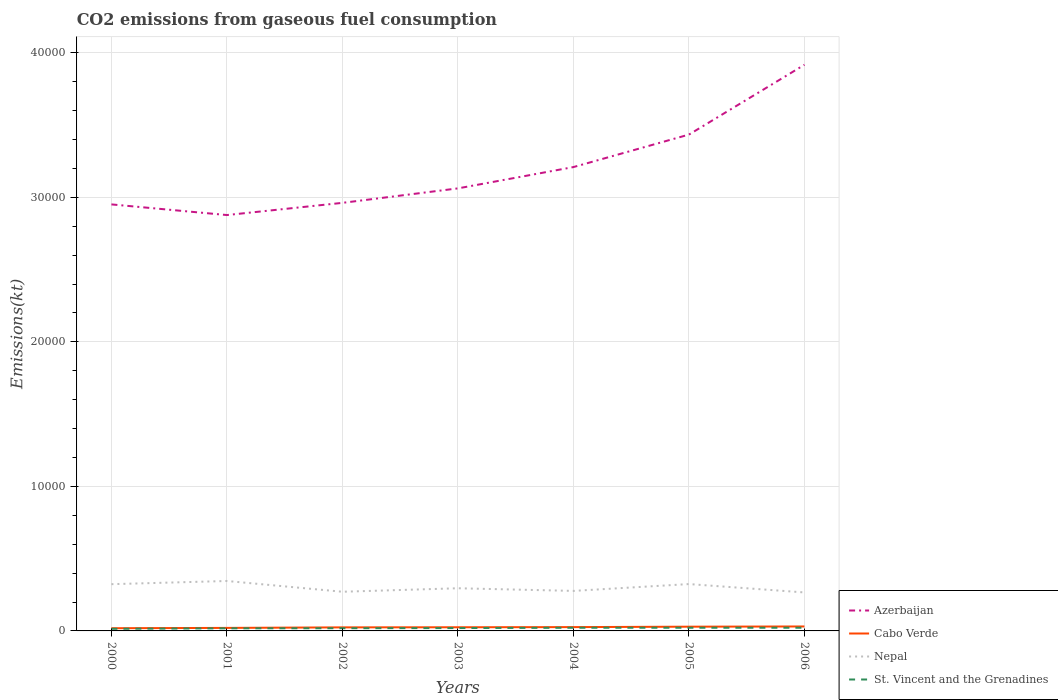Across all years, what is the maximum amount of CO2 emitted in Cabo Verde?
Provide a succinct answer. 187.02. What is the total amount of CO2 emitted in Azerbaijan in the graph?
Your response must be concise. -2247.87. What is the difference between the highest and the second highest amount of CO2 emitted in Nepal?
Your answer should be very brief. 792.07. How many years are there in the graph?
Your answer should be compact. 7. Does the graph contain any zero values?
Provide a succinct answer. No. How many legend labels are there?
Offer a terse response. 4. What is the title of the graph?
Offer a very short reply. CO2 emissions from gaseous fuel consumption. Does "Sint Maarten (Dutch part)" appear as one of the legend labels in the graph?
Your answer should be compact. No. What is the label or title of the Y-axis?
Your response must be concise. Emissions(kt). What is the Emissions(kt) in Azerbaijan in 2000?
Offer a terse response. 2.95e+04. What is the Emissions(kt) of Cabo Verde in 2000?
Your answer should be very brief. 187.02. What is the Emissions(kt) of Nepal in 2000?
Offer a very short reply. 3234.29. What is the Emissions(kt) of St. Vincent and the Grenadines in 2000?
Provide a short and direct response. 146.68. What is the Emissions(kt) in Azerbaijan in 2001?
Make the answer very short. 2.88e+04. What is the Emissions(kt) of Cabo Verde in 2001?
Give a very brief answer. 209.02. What is the Emissions(kt) of Nepal in 2001?
Offer a very short reply. 3454.31. What is the Emissions(kt) in St. Vincent and the Grenadines in 2001?
Your response must be concise. 179.68. What is the Emissions(kt) of Azerbaijan in 2002?
Give a very brief answer. 2.96e+04. What is the Emissions(kt) in Cabo Verde in 2002?
Your answer should be very brief. 245.69. What is the Emissions(kt) of Nepal in 2002?
Give a very brief answer. 2709.91. What is the Emissions(kt) in St. Vincent and the Grenadines in 2002?
Your answer should be compact. 187.02. What is the Emissions(kt) in Azerbaijan in 2003?
Keep it short and to the point. 3.06e+04. What is the Emissions(kt) of Cabo Verde in 2003?
Offer a very short reply. 253.02. What is the Emissions(kt) of Nepal in 2003?
Ensure brevity in your answer.  2951.93. What is the Emissions(kt) in St. Vincent and the Grenadines in 2003?
Ensure brevity in your answer.  198.02. What is the Emissions(kt) in Azerbaijan in 2004?
Offer a terse response. 3.21e+04. What is the Emissions(kt) in Cabo Verde in 2004?
Keep it short and to the point. 264.02. What is the Emissions(kt) of Nepal in 2004?
Offer a very short reply. 2768.59. What is the Emissions(kt) of St. Vincent and the Grenadines in 2004?
Ensure brevity in your answer.  220.02. What is the Emissions(kt) of Azerbaijan in 2005?
Keep it short and to the point. 3.43e+04. What is the Emissions(kt) in Cabo Verde in 2005?
Provide a succinct answer. 293.36. What is the Emissions(kt) of Nepal in 2005?
Make the answer very short. 3241.63. What is the Emissions(kt) in St. Vincent and the Grenadines in 2005?
Give a very brief answer. 220.02. What is the Emissions(kt) of Azerbaijan in 2006?
Your answer should be compact. 3.92e+04. What is the Emissions(kt) of Cabo Verde in 2006?
Offer a terse response. 308.03. What is the Emissions(kt) of Nepal in 2006?
Offer a terse response. 2662.24. What is the Emissions(kt) in St. Vincent and the Grenadines in 2006?
Make the answer very short. 220.02. Across all years, what is the maximum Emissions(kt) of Azerbaijan?
Your answer should be very brief. 3.92e+04. Across all years, what is the maximum Emissions(kt) of Cabo Verde?
Your answer should be compact. 308.03. Across all years, what is the maximum Emissions(kt) of Nepal?
Make the answer very short. 3454.31. Across all years, what is the maximum Emissions(kt) of St. Vincent and the Grenadines?
Offer a very short reply. 220.02. Across all years, what is the minimum Emissions(kt) of Azerbaijan?
Ensure brevity in your answer.  2.88e+04. Across all years, what is the minimum Emissions(kt) in Cabo Verde?
Your response must be concise. 187.02. Across all years, what is the minimum Emissions(kt) of Nepal?
Ensure brevity in your answer.  2662.24. Across all years, what is the minimum Emissions(kt) in St. Vincent and the Grenadines?
Provide a succinct answer. 146.68. What is the total Emissions(kt) in Azerbaijan in the graph?
Provide a succinct answer. 2.24e+05. What is the total Emissions(kt) of Cabo Verde in the graph?
Keep it short and to the point. 1760.16. What is the total Emissions(kt) in Nepal in the graph?
Give a very brief answer. 2.10e+04. What is the total Emissions(kt) in St. Vincent and the Grenadines in the graph?
Provide a succinct answer. 1371.46. What is the difference between the Emissions(kt) in Azerbaijan in 2000 and that in 2001?
Your answer should be compact. 737.07. What is the difference between the Emissions(kt) in Cabo Verde in 2000 and that in 2001?
Give a very brief answer. -22. What is the difference between the Emissions(kt) of Nepal in 2000 and that in 2001?
Your response must be concise. -220.02. What is the difference between the Emissions(kt) in St. Vincent and the Grenadines in 2000 and that in 2001?
Keep it short and to the point. -33. What is the difference between the Emissions(kt) of Azerbaijan in 2000 and that in 2002?
Keep it short and to the point. -106.34. What is the difference between the Emissions(kt) of Cabo Verde in 2000 and that in 2002?
Give a very brief answer. -58.67. What is the difference between the Emissions(kt) in Nepal in 2000 and that in 2002?
Your answer should be very brief. 524.38. What is the difference between the Emissions(kt) in St. Vincent and the Grenadines in 2000 and that in 2002?
Make the answer very short. -40.34. What is the difference between the Emissions(kt) of Azerbaijan in 2000 and that in 2003?
Offer a terse response. -1107.43. What is the difference between the Emissions(kt) of Cabo Verde in 2000 and that in 2003?
Provide a succinct answer. -66.01. What is the difference between the Emissions(kt) in Nepal in 2000 and that in 2003?
Your answer should be very brief. 282.36. What is the difference between the Emissions(kt) in St. Vincent and the Grenadines in 2000 and that in 2003?
Offer a terse response. -51.34. What is the difference between the Emissions(kt) in Azerbaijan in 2000 and that in 2004?
Provide a succinct answer. -2581.57. What is the difference between the Emissions(kt) of Cabo Verde in 2000 and that in 2004?
Make the answer very short. -77.01. What is the difference between the Emissions(kt) of Nepal in 2000 and that in 2004?
Your answer should be very brief. 465.71. What is the difference between the Emissions(kt) of St. Vincent and the Grenadines in 2000 and that in 2004?
Offer a very short reply. -73.34. What is the difference between the Emissions(kt) of Azerbaijan in 2000 and that in 2005?
Offer a very short reply. -4829.44. What is the difference between the Emissions(kt) in Cabo Verde in 2000 and that in 2005?
Your response must be concise. -106.34. What is the difference between the Emissions(kt) in Nepal in 2000 and that in 2005?
Keep it short and to the point. -7.33. What is the difference between the Emissions(kt) of St. Vincent and the Grenadines in 2000 and that in 2005?
Give a very brief answer. -73.34. What is the difference between the Emissions(kt) in Azerbaijan in 2000 and that in 2006?
Keep it short and to the point. -9658.88. What is the difference between the Emissions(kt) in Cabo Verde in 2000 and that in 2006?
Make the answer very short. -121.01. What is the difference between the Emissions(kt) of Nepal in 2000 and that in 2006?
Keep it short and to the point. 572.05. What is the difference between the Emissions(kt) of St. Vincent and the Grenadines in 2000 and that in 2006?
Offer a very short reply. -73.34. What is the difference between the Emissions(kt) of Azerbaijan in 2001 and that in 2002?
Ensure brevity in your answer.  -843.41. What is the difference between the Emissions(kt) in Cabo Verde in 2001 and that in 2002?
Provide a succinct answer. -36.67. What is the difference between the Emissions(kt) in Nepal in 2001 and that in 2002?
Provide a succinct answer. 744.4. What is the difference between the Emissions(kt) of St. Vincent and the Grenadines in 2001 and that in 2002?
Your answer should be compact. -7.33. What is the difference between the Emissions(kt) of Azerbaijan in 2001 and that in 2003?
Keep it short and to the point. -1844.5. What is the difference between the Emissions(kt) in Cabo Verde in 2001 and that in 2003?
Give a very brief answer. -44. What is the difference between the Emissions(kt) of Nepal in 2001 and that in 2003?
Your answer should be very brief. 502.38. What is the difference between the Emissions(kt) of St. Vincent and the Grenadines in 2001 and that in 2003?
Ensure brevity in your answer.  -18.34. What is the difference between the Emissions(kt) of Azerbaijan in 2001 and that in 2004?
Provide a succinct answer. -3318.64. What is the difference between the Emissions(kt) of Cabo Verde in 2001 and that in 2004?
Your answer should be very brief. -55.01. What is the difference between the Emissions(kt) in Nepal in 2001 and that in 2004?
Provide a short and direct response. 685.73. What is the difference between the Emissions(kt) in St. Vincent and the Grenadines in 2001 and that in 2004?
Provide a succinct answer. -40.34. What is the difference between the Emissions(kt) of Azerbaijan in 2001 and that in 2005?
Provide a succinct answer. -5566.51. What is the difference between the Emissions(kt) in Cabo Verde in 2001 and that in 2005?
Offer a terse response. -84.34. What is the difference between the Emissions(kt) of Nepal in 2001 and that in 2005?
Your answer should be compact. 212.69. What is the difference between the Emissions(kt) of St. Vincent and the Grenadines in 2001 and that in 2005?
Your answer should be compact. -40.34. What is the difference between the Emissions(kt) in Azerbaijan in 2001 and that in 2006?
Your answer should be very brief. -1.04e+04. What is the difference between the Emissions(kt) of Cabo Verde in 2001 and that in 2006?
Your answer should be very brief. -99.01. What is the difference between the Emissions(kt) in Nepal in 2001 and that in 2006?
Provide a short and direct response. 792.07. What is the difference between the Emissions(kt) in St. Vincent and the Grenadines in 2001 and that in 2006?
Your response must be concise. -40.34. What is the difference between the Emissions(kt) in Azerbaijan in 2002 and that in 2003?
Provide a short and direct response. -1001.09. What is the difference between the Emissions(kt) in Cabo Verde in 2002 and that in 2003?
Keep it short and to the point. -7.33. What is the difference between the Emissions(kt) in Nepal in 2002 and that in 2003?
Provide a succinct answer. -242.02. What is the difference between the Emissions(kt) of St. Vincent and the Grenadines in 2002 and that in 2003?
Give a very brief answer. -11. What is the difference between the Emissions(kt) in Azerbaijan in 2002 and that in 2004?
Offer a terse response. -2475.22. What is the difference between the Emissions(kt) of Cabo Verde in 2002 and that in 2004?
Your answer should be compact. -18.34. What is the difference between the Emissions(kt) of Nepal in 2002 and that in 2004?
Your response must be concise. -58.67. What is the difference between the Emissions(kt) of St. Vincent and the Grenadines in 2002 and that in 2004?
Ensure brevity in your answer.  -33. What is the difference between the Emissions(kt) of Azerbaijan in 2002 and that in 2005?
Your answer should be compact. -4723.1. What is the difference between the Emissions(kt) in Cabo Verde in 2002 and that in 2005?
Give a very brief answer. -47.67. What is the difference between the Emissions(kt) of Nepal in 2002 and that in 2005?
Ensure brevity in your answer.  -531.72. What is the difference between the Emissions(kt) in St. Vincent and the Grenadines in 2002 and that in 2005?
Provide a short and direct response. -33. What is the difference between the Emissions(kt) in Azerbaijan in 2002 and that in 2006?
Offer a very short reply. -9552.53. What is the difference between the Emissions(kt) of Cabo Verde in 2002 and that in 2006?
Give a very brief answer. -62.34. What is the difference between the Emissions(kt) of Nepal in 2002 and that in 2006?
Offer a very short reply. 47.67. What is the difference between the Emissions(kt) of St. Vincent and the Grenadines in 2002 and that in 2006?
Keep it short and to the point. -33. What is the difference between the Emissions(kt) in Azerbaijan in 2003 and that in 2004?
Provide a succinct answer. -1474.13. What is the difference between the Emissions(kt) of Cabo Verde in 2003 and that in 2004?
Offer a very short reply. -11. What is the difference between the Emissions(kt) of Nepal in 2003 and that in 2004?
Make the answer very short. 183.35. What is the difference between the Emissions(kt) of St. Vincent and the Grenadines in 2003 and that in 2004?
Offer a very short reply. -22. What is the difference between the Emissions(kt) in Azerbaijan in 2003 and that in 2005?
Your response must be concise. -3722.01. What is the difference between the Emissions(kt) of Cabo Verde in 2003 and that in 2005?
Give a very brief answer. -40.34. What is the difference between the Emissions(kt) in Nepal in 2003 and that in 2005?
Your response must be concise. -289.69. What is the difference between the Emissions(kt) of St. Vincent and the Grenadines in 2003 and that in 2005?
Your response must be concise. -22. What is the difference between the Emissions(kt) in Azerbaijan in 2003 and that in 2006?
Your answer should be very brief. -8551.44. What is the difference between the Emissions(kt) in Cabo Verde in 2003 and that in 2006?
Your response must be concise. -55.01. What is the difference between the Emissions(kt) in Nepal in 2003 and that in 2006?
Offer a very short reply. 289.69. What is the difference between the Emissions(kt) in St. Vincent and the Grenadines in 2003 and that in 2006?
Make the answer very short. -22. What is the difference between the Emissions(kt) in Azerbaijan in 2004 and that in 2005?
Offer a very short reply. -2247.87. What is the difference between the Emissions(kt) of Cabo Verde in 2004 and that in 2005?
Provide a succinct answer. -29.34. What is the difference between the Emissions(kt) of Nepal in 2004 and that in 2005?
Make the answer very short. -473.04. What is the difference between the Emissions(kt) in Azerbaijan in 2004 and that in 2006?
Offer a terse response. -7077.31. What is the difference between the Emissions(kt) in Cabo Verde in 2004 and that in 2006?
Your answer should be very brief. -44. What is the difference between the Emissions(kt) of Nepal in 2004 and that in 2006?
Keep it short and to the point. 106.34. What is the difference between the Emissions(kt) in Azerbaijan in 2005 and that in 2006?
Make the answer very short. -4829.44. What is the difference between the Emissions(kt) in Cabo Verde in 2005 and that in 2006?
Your response must be concise. -14.67. What is the difference between the Emissions(kt) of Nepal in 2005 and that in 2006?
Offer a very short reply. 579.39. What is the difference between the Emissions(kt) in Azerbaijan in 2000 and the Emissions(kt) in Cabo Verde in 2001?
Provide a succinct answer. 2.93e+04. What is the difference between the Emissions(kt) in Azerbaijan in 2000 and the Emissions(kt) in Nepal in 2001?
Offer a very short reply. 2.61e+04. What is the difference between the Emissions(kt) of Azerbaijan in 2000 and the Emissions(kt) of St. Vincent and the Grenadines in 2001?
Ensure brevity in your answer.  2.93e+04. What is the difference between the Emissions(kt) of Cabo Verde in 2000 and the Emissions(kt) of Nepal in 2001?
Ensure brevity in your answer.  -3267.3. What is the difference between the Emissions(kt) in Cabo Verde in 2000 and the Emissions(kt) in St. Vincent and the Grenadines in 2001?
Provide a short and direct response. 7.33. What is the difference between the Emissions(kt) of Nepal in 2000 and the Emissions(kt) of St. Vincent and the Grenadines in 2001?
Your response must be concise. 3054.61. What is the difference between the Emissions(kt) in Azerbaijan in 2000 and the Emissions(kt) in Cabo Verde in 2002?
Offer a very short reply. 2.93e+04. What is the difference between the Emissions(kt) of Azerbaijan in 2000 and the Emissions(kt) of Nepal in 2002?
Your response must be concise. 2.68e+04. What is the difference between the Emissions(kt) of Azerbaijan in 2000 and the Emissions(kt) of St. Vincent and the Grenadines in 2002?
Offer a terse response. 2.93e+04. What is the difference between the Emissions(kt) of Cabo Verde in 2000 and the Emissions(kt) of Nepal in 2002?
Give a very brief answer. -2522.9. What is the difference between the Emissions(kt) in Cabo Verde in 2000 and the Emissions(kt) in St. Vincent and the Grenadines in 2002?
Keep it short and to the point. 0. What is the difference between the Emissions(kt) of Nepal in 2000 and the Emissions(kt) of St. Vincent and the Grenadines in 2002?
Keep it short and to the point. 3047.28. What is the difference between the Emissions(kt) of Azerbaijan in 2000 and the Emissions(kt) of Cabo Verde in 2003?
Provide a succinct answer. 2.93e+04. What is the difference between the Emissions(kt) of Azerbaijan in 2000 and the Emissions(kt) of Nepal in 2003?
Offer a terse response. 2.66e+04. What is the difference between the Emissions(kt) of Azerbaijan in 2000 and the Emissions(kt) of St. Vincent and the Grenadines in 2003?
Your answer should be compact. 2.93e+04. What is the difference between the Emissions(kt) of Cabo Verde in 2000 and the Emissions(kt) of Nepal in 2003?
Offer a terse response. -2764.92. What is the difference between the Emissions(kt) of Cabo Verde in 2000 and the Emissions(kt) of St. Vincent and the Grenadines in 2003?
Your response must be concise. -11. What is the difference between the Emissions(kt) in Nepal in 2000 and the Emissions(kt) in St. Vincent and the Grenadines in 2003?
Offer a terse response. 3036.28. What is the difference between the Emissions(kt) of Azerbaijan in 2000 and the Emissions(kt) of Cabo Verde in 2004?
Offer a terse response. 2.92e+04. What is the difference between the Emissions(kt) of Azerbaijan in 2000 and the Emissions(kt) of Nepal in 2004?
Keep it short and to the point. 2.67e+04. What is the difference between the Emissions(kt) in Azerbaijan in 2000 and the Emissions(kt) in St. Vincent and the Grenadines in 2004?
Provide a short and direct response. 2.93e+04. What is the difference between the Emissions(kt) of Cabo Verde in 2000 and the Emissions(kt) of Nepal in 2004?
Provide a short and direct response. -2581.57. What is the difference between the Emissions(kt) of Cabo Verde in 2000 and the Emissions(kt) of St. Vincent and the Grenadines in 2004?
Offer a very short reply. -33. What is the difference between the Emissions(kt) of Nepal in 2000 and the Emissions(kt) of St. Vincent and the Grenadines in 2004?
Make the answer very short. 3014.27. What is the difference between the Emissions(kt) in Azerbaijan in 2000 and the Emissions(kt) in Cabo Verde in 2005?
Make the answer very short. 2.92e+04. What is the difference between the Emissions(kt) in Azerbaijan in 2000 and the Emissions(kt) in Nepal in 2005?
Your response must be concise. 2.63e+04. What is the difference between the Emissions(kt) in Azerbaijan in 2000 and the Emissions(kt) in St. Vincent and the Grenadines in 2005?
Your answer should be compact. 2.93e+04. What is the difference between the Emissions(kt) of Cabo Verde in 2000 and the Emissions(kt) of Nepal in 2005?
Your response must be concise. -3054.61. What is the difference between the Emissions(kt) in Cabo Verde in 2000 and the Emissions(kt) in St. Vincent and the Grenadines in 2005?
Offer a terse response. -33. What is the difference between the Emissions(kt) of Nepal in 2000 and the Emissions(kt) of St. Vincent and the Grenadines in 2005?
Your response must be concise. 3014.27. What is the difference between the Emissions(kt) of Azerbaijan in 2000 and the Emissions(kt) of Cabo Verde in 2006?
Keep it short and to the point. 2.92e+04. What is the difference between the Emissions(kt) of Azerbaijan in 2000 and the Emissions(kt) of Nepal in 2006?
Provide a succinct answer. 2.68e+04. What is the difference between the Emissions(kt) in Azerbaijan in 2000 and the Emissions(kt) in St. Vincent and the Grenadines in 2006?
Provide a short and direct response. 2.93e+04. What is the difference between the Emissions(kt) of Cabo Verde in 2000 and the Emissions(kt) of Nepal in 2006?
Make the answer very short. -2475.22. What is the difference between the Emissions(kt) in Cabo Verde in 2000 and the Emissions(kt) in St. Vincent and the Grenadines in 2006?
Provide a succinct answer. -33. What is the difference between the Emissions(kt) in Nepal in 2000 and the Emissions(kt) in St. Vincent and the Grenadines in 2006?
Offer a very short reply. 3014.27. What is the difference between the Emissions(kt) in Azerbaijan in 2001 and the Emissions(kt) in Cabo Verde in 2002?
Offer a very short reply. 2.85e+04. What is the difference between the Emissions(kt) of Azerbaijan in 2001 and the Emissions(kt) of Nepal in 2002?
Provide a succinct answer. 2.61e+04. What is the difference between the Emissions(kt) of Azerbaijan in 2001 and the Emissions(kt) of St. Vincent and the Grenadines in 2002?
Your response must be concise. 2.86e+04. What is the difference between the Emissions(kt) in Cabo Verde in 2001 and the Emissions(kt) in Nepal in 2002?
Provide a succinct answer. -2500.89. What is the difference between the Emissions(kt) in Cabo Verde in 2001 and the Emissions(kt) in St. Vincent and the Grenadines in 2002?
Offer a terse response. 22. What is the difference between the Emissions(kt) of Nepal in 2001 and the Emissions(kt) of St. Vincent and the Grenadines in 2002?
Offer a terse response. 3267.3. What is the difference between the Emissions(kt) of Azerbaijan in 2001 and the Emissions(kt) of Cabo Verde in 2003?
Your response must be concise. 2.85e+04. What is the difference between the Emissions(kt) in Azerbaijan in 2001 and the Emissions(kt) in Nepal in 2003?
Offer a terse response. 2.58e+04. What is the difference between the Emissions(kt) in Azerbaijan in 2001 and the Emissions(kt) in St. Vincent and the Grenadines in 2003?
Make the answer very short. 2.86e+04. What is the difference between the Emissions(kt) in Cabo Verde in 2001 and the Emissions(kt) in Nepal in 2003?
Your answer should be compact. -2742.92. What is the difference between the Emissions(kt) in Cabo Verde in 2001 and the Emissions(kt) in St. Vincent and the Grenadines in 2003?
Give a very brief answer. 11. What is the difference between the Emissions(kt) of Nepal in 2001 and the Emissions(kt) of St. Vincent and the Grenadines in 2003?
Your answer should be compact. 3256.3. What is the difference between the Emissions(kt) of Azerbaijan in 2001 and the Emissions(kt) of Cabo Verde in 2004?
Give a very brief answer. 2.85e+04. What is the difference between the Emissions(kt) of Azerbaijan in 2001 and the Emissions(kt) of Nepal in 2004?
Give a very brief answer. 2.60e+04. What is the difference between the Emissions(kt) in Azerbaijan in 2001 and the Emissions(kt) in St. Vincent and the Grenadines in 2004?
Offer a terse response. 2.86e+04. What is the difference between the Emissions(kt) in Cabo Verde in 2001 and the Emissions(kt) in Nepal in 2004?
Keep it short and to the point. -2559.57. What is the difference between the Emissions(kt) in Cabo Verde in 2001 and the Emissions(kt) in St. Vincent and the Grenadines in 2004?
Offer a very short reply. -11. What is the difference between the Emissions(kt) of Nepal in 2001 and the Emissions(kt) of St. Vincent and the Grenadines in 2004?
Offer a very short reply. 3234.29. What is the difference between the Emissions(kt) of Azerbaijan in 2001 and the Emissions(kt) of Cabo Verde in 2005?
Provide a succinct answer. 2.85e+04. What is the difference between the Emissions(kt) in Azerbaijan in 2001 and the Emissions(kt) in Nepal in 2005?
Your answer should be very brief. 2.55e+04. What is the difference between the Emissions(kt) of Azerbaijan in 2001 and the Emissions(kt) of St. Vincent and the Grenadines in 2005?
Your answer should be compact. 2.86e+04. What is the difference between the Emissions(kt) in Cabo Verde in 2001 and the Emissions(kt) in Nepal in 2005?
Give a very brief answer. -3032.61. What is the difference between the Emissions(kt) of Cabo Verde in 2001 and the Emissions(kt) of St. Vincent and the Grenadines in 2005?
Make the answer very short. -11. What is the difference between the Emissions(kt) of Nepal in 2001 and the Emissions(kt) of St. Vincent and the Grenadines in 2005?
Give a very brief answer. 3234.29. What is the difference between the Emissions(kt) of Azerbaijan in 2001 and the Emissions(kt) of Cabo Verde in 2006?
Give a very brief answer. 2.85e+04. What is the difference between the Emissions(kt) of Azerbaijan in 2001 and the Emissions(kt) of Nepal in 2006?
Provide a succinct answer. 2.61e+04. What is the difference between the Emissions(kt) in Azerbaijan in 2001 and the Emissions(kt) in St. Vincent and the Grenadines in 2006?
Provide a succinct answer. 2.86e+04. What is the difference between the Emissions(kt) of Cabo Verde in 2001 and the Emissions(kt) of Nepal in 2006?
Ensure brevity in your answer.  -2453.22. What is the difference between the Emissions(kt) in Cabo Verde in 2001 and the Emissions(kt) in St. Vincent and the Grenadines in 2006?
Keep it short and to the point. -11. What is the difference between the Emissions(kt) of Nepal in 2001 and the Emissions(kt) of St. Vincent and the Grenadines in 2006?
Ensure brevity in your answer.  3234.29. What is the difference between the Emissions(kt) in Azerbaijan in 2002 and the Emissions(kt) in Cabo Verde in 2003?
Your answer should be compact. 2.94e+04. What is the difference between the Emissions(kt) of Azerbaijan in 2002 and the Emissions(kt) of Nepal in 2003?
Offer a very short reply. 2.67e+04. What is the difference between the Emissions(kt) in Azerbaijan in 2002 and the Emissions(kt) in St. Vincent and the Grenadines in 2003?
Give a very brief answer. 2.94e+04. What is the difference between the Emissions(kt) in Cabo Verde in 2002 and the Emissions(kt) in Nepal in 2003?
Your answer should be very brief. -2706.25. What is the difference between the Emissions(kt) in Cabo Verde in 2002 and the Emissions(kt) in St. Vincent and the Grenadines in 2003?
Offer a terse response. 47.67. What is the difference between the Emissions(kt) in Nepal in 2002 and the Emissions(kt) in St. Vincent and the Grenadines in 2003?
Ensure brevity in your answer.  2511.89. What is the difference between the Emissions(kt) of Azerbaijan in 2002 and the Emissions(kt) of Cabo Verde in 2004?
Make the answer very short. 2.94e+04. What is the difference between the Emissions(kt) of Azerbaijan in 2002 and the Emissions(kt) of Nepal in 2004?
Offer a very short reply. 2.68e+04. What is the difference between the Emissions(kt) in Azerbaijan in 2002 and the Emissions(kt) in St. Vincent and the Grenadines in 2004?
Offer a terse response. 2.94e+04. What is the difference between the Emissions(kt) of Cabo Verde in 2002 and the Emissions(kt) of Nepal in 2004?
Offer a terse response. -2522.9. What is the difference between the Emissions(kt) in Cabo Verde in 2002 and the Emissions(kt) in St. Vincent and the Grenadines in 2004?
Give a very brief answer. 25.67. What is the difference between the Emissions(kt) in Nepal in 2002 and the Emissions(kt) in St. Vincent and the Grenadines in 2004?
Make the answer very short. 2489.89. What is the difference between the Emissions(kt) in Azerbaijan in 2002 and the Emissions(kt) in Cabo Verde in 2005?
Provide a succinct answer. 2.93e+04. What is the difference between the Emissions(kt) in Azerbaijan in 2002 and the Emissions(kt) in Nepal in 2005?
Provide a succinct answer. 2.64e+04. What is the difference between the Emissions(kt) in Azerbaijan in 2002 and the Emissions(kt) in St. Vincent and the Grenadines in 2005?
Provide a succinct answer. 2.94e+04. What is the difference between the Emissions(kt) in Cabo Verde in 2002 and the Emissions(kt) in Nepal in 2005?
Your response must be concise. -2995.94. What is the difference between the Emissions(kt) of Cabo Verde in 2002 and the Emissions(kt) of St. Vincent and the Grenadines in 2005?
Ensure brevity in your answer.  25.67. What is the difference between the Emissions(kt) in Nepal in 2002 and the Emissions(kt) in St. Vincent and the Grenadines in 2005?
Give a very brief answer. 2489.89. What is the difference between the Emissions(kt) of Azerbaijan in 2002 and the Emissions(kt) of Cabo Verde in 2006?
Offer a terse response. 2.93e+04. What is the difference between the Emissions(kt) of Azerbaijan in 2002 and the Emissions(kt) of Nepal in 2006?
Offer a terse response. 2.70e+04. What is the difference between the Emissions(kt) in Azerbaijan in 2002 and the Emissions(kt) in St. Vincent and the Grenadines in 2006?
Your answer should be compact. 2.94e+04. What is the difference between the Emissions(kt) of Cabo Verde in 2002 and the Emissions(kt) of Nepal in 2006?
Offer a very short reply. -2416.55. What is the difference between the Emissions(kt) in Cabo Verde in 2002 and the Emissions(kt) in St. Vincent and the Grenadines in 2006?
Make the answer very short. 25.67. What is the difference between the Emissions(kt) in Nepal in 2002 and the Emissions(kt) in St. Vincent and the Grenadines in 2006?
Offer a terse response. 2489.89. What is the difference between the Emissions(kt) of Azerbaijan in 2003 and the Emissions(kt) of Cabo Verde in 2004?
Provide a succinct answer. 3.04e+04. What is the difference between the Emissions(kt) of Azerbaijan in 2003 and the Emissions(kt) of Nepal in 2004?
Ensure brevity in your answer.  2.78e+04. What is the difference between the Emissions(kt) of Azerbaijan in 2003 and the Emissions(kt) of St. Vincent and the Grenadines in 2004?
Offer a terse response. 3.04e+04. What is the difference between the Emissions(kt) in Cabo Verde in 2003 and the Emissions(kt) in Nepal in 2004?
Provide a succinct answer. -2515.56. What is the difference between the Emissions(kt) of Cabo Verde in 2003 and the Emissions(kt) of St. Vincent and the Grenadines in 2004?
Your response must be concise. 33. What is the difference between the Emissions(kt) in Nepal in 2003 and the Emissions(kt) in St. Vincent and the Grenadines in 2004?
Your response must be concise. 2731.91. What is the difference between the Emissions(kt) of Azerbaijan in 2003 and the Emissions(kt) of Cabo Verde in 2005?
Keep it short and to the point. 3.03e+04. What is the difference between the Emissions(kt) in Azerbaijan in 2003 and the Emissions(kt) in Nepal in 2005?
Keep it short and to the point. 2.74e+04. What is the difference between the Emissions(kt) of Azerbaijan in 2003 and the Emissions(kt) of St. Vincent and the Grenadines in 2005?
Your response must be concise. 3.04e+04. What is the difference between the Emissions(kt) in Cabo Verde in 2003 and the Emissions(kt) in Nepal in 2005?
Provide a succinct answer. -2988.61. What is the difference between the Emissions(kt) in Cabo Verde in 2003 and the Emissions(kt) in St. Vincent and the Grenadines in 2005?
Provide a short and direct response. 33. What is the difference between the Emissions(kt) of Nepal in 2003 and the Emissions(kt) of St. Vincent and the Grenadines in 2005?
Offer a terse response. 2731.91. What is the difference between the Emissions(kt) in Azerbaijan in 2003 and the Emissions(kt) in Cabo Verde in 2006?
Keep it short and to the point. 3.03e+04. What is the difference between the Emissions(kt) of Azerbaijan in 2003 and the Emissions(kt) of Nepal in 2006?
Give a very brief answer. 2.80e+04. What is the difference between the Emissions(kt) of Azerbaijan in 2003 and the Emissions(kt) of St. Vincent and the Grenadines in 2006?
Provide a succinct answer. 3.04e+04. What is the difference between the Emissions(kt) in Cabo Verde in 2003 and the Emissions(kt) in Nepal in 2006?
Your answer should be very brief. -2409.22. What is the difference between the Emissions(kt) in Cabo Verde in 2003 and the Emissions(kt) in St. Vincent and the Grenadines in 2006?
Offer a terse response. 33. What is the difference between the Emissions(kt) in Nepal in 2003 and the Emissions(kt) in St. Vincent and the Grenadines in 2006?
Offer a terse response. 2731.91. What is the difference between the Emissions(kt) in Azerbaijan in 2004 and the Emissions(kt) in Cabo Verde in 2005?
Your answer should be very brief. 3.18e+04. What is the difference between the Emissions(kt) in Azerbaijan in 2004 and the Emissions(kt) in Nepal in 2005?
Offer a very short reply. 2.88e+04. What is the difference between the Emissions(kt) in Azerbaijan in 2004 and the Emissions(kt) in St. Vincent and the Grenadines in 2005?
Provide a short and direct response. 3.19e+04. What is the difference between the Emissions(kt) of Cabo Verde in 2004 and the Emissions(kt) of Nepal in 2005?
Your answer should be compact. -2977.6. What is the difference between the Emissions(kt) in Cabo Verde in 2004 and the Emissions(kt) in St. Vincent and the Grenadines in 2005?
Ensure brevity in your answer.  44. What is the difference between the Emissions(kt) in Nepal in 2004 and the Emissions(kt) in St. Vincent and the Grenadines in 2005?
Make the answer very short. 2548.57. What is the difference between the Emissions(kt) in Azerbaijan in 2004 and the Emissions(kt) in Cabo Verde in 2006?
Make the answer very short. 3.18e+04. What is the difference between the Emissions(kt) of Azerbaijan in 2004 and the Emissions(kt) of Nepal in 2006?
Offer a terse response. 2.94e+04. What is the difference between the Emissions(kt) of Azerbaijan in 2004 and the Emissions(kt) of St. Vincent and the Grenadines in 2006?
Your answer should be compact. 3.19e+04. What is the difference between the Emissions(kt) of Cabo Verde in 2004 and the Emissions(kt) of Nepal in 2006?
Offer a very short reply. -2398.22. What is the difference between the Emissions(kt) in Cabo Verde in 2004 and the Emissions(kt) in St. Vincent and the Grenadines in 2006?
Offer a very short reply. 44. What is the difference between the Emissions(kt) of Nepal in 2004 and the Emissions(kt) of St. Vincent and the Grenadines in 2006?
Keep it short and to the point. 2548.57. What is the difference between the Emissions(kt) of Azerbaijan in 2005 and the Emissions(kt) of Cabo Verde in 2006?
Make the answer very short. 3.40e+04. What is the difference between the Emissions(kt) of Azerbaijan in 2005 and the Emissions(kt) of Nepal in 2006?
Provide a short and direct response. 3.17e+04. What is the difference between the Emissions(kt) in Azerbaijan in 2005 and the Emissions(kt) in St. Vincent and the Grenadines in 2006?
Give a very brief answer. 3.41e+04. What is the difference between the Emissions(kt) of Cabo Verde in 2005 and the Emissions(kt) of Nepal in 2006?
Provide a succinct answer. -2368.88. What is the difference between the Emissions(kt) of Cabo Verde in 2005 and the Emissions(kt) of St. Vincent and the Grenadines in 2006?
Make the answer very short. 73.34. What is the difference between the Emissions(kt) in Nepal in 2005 and the Emissions(kt) in St. Vincent and the Grenadines in 2006?
Offer a very short reply. 3021.61. What is the average Emissions(kt) in Azerbaijan per year?
Give a very brief answer. 3.20e+04. What is the average Emissions(kt) in Cabo Verde per year?
Give a very brief answer. 251.45. What is the average Emissions(kt) of Nepal per year?
Keep it short and to the point. 3003.27. What is the average Emissions(kt) of St. Vincent and the Grenadines per year?
Offer a very short reply. 195.92. In the year 2000, what is the difference between the Emissions(kt) in Azerbaijan and Emissions(kt) in Cabo Verde?
Ensure brevity in your answer.  2.93e+04. In the year 2000, what is the difference between the Emissions(kt) in Azerbaijan and Emissions(kt) in Nepal?
Offer a terse response. 2.63e+04. In the year 2000, what is the difference between the Emissions(kt) of Azerbaijan and Emissions(kt) of St. Vincent and the Grenadines?
Make the answer very short. 2.94e+04. In the year 2000, what is the difference between the Emissions(kt) of Cabo Verde and Emissions(kt) of Nepal?
Offer a terse response. -3047.28. In the year 2000, what is the difference between the Emissions(kt) in Cabo Verde and Emissions(kt) in St. Vincent and the Grenadines?
Your answer should be compact. 40.34. In the year 2000, what is the difference between the Emissions(kt) of Nepal and Emissions(kt) of St. Vincent and the Grenadines?
Your response must be concise. 3087.61. In the year 2001, what is the difference between the Emissions(kt) in Azerbaijan and Emissions(kt) in Cabo Verde?
Your answer should be compact. 2.86e+04. In the year 2001, what is the difference between the Emissions(kt) in Azerbaijan and Emissions(kt) in Nepal?
Give a very brief answer. 2.53e+04. In the year 2001, what is the difference between the Emissions(kt) of Azerbaijan and Emissions(kt) of St. Vincent and the Grenadines?
Your response must be concise. 2.86e+04. In the year 2001, what is the difference between the Emissions(kt) of Cabo Verde and Emissions(kt) of Nepal?
Give a very brief answer. -3245.3. In the year 2001, what is the difference between the Emissions(kt) of Cabo Verde and Emissions(kt) of St. Vincent and the Grenadines?
Your answer should be very brief. 29.34. In the year 2001, what is the difference between the Emissions(kt) in Nepal and Emissions(kt) in St. Vincent and the Grenadines?
Your answer should be compact. 3274.63. In the year 2002, what is the difference between the Emissions(kt) in Azerbaijan and Emissions(kt) in Cabo Verde?
Offer a terse response. 2.94e+04. In the year 2002, what is the difference between the Emissions(kt) of Azerbaijan and Emissions(kt) of Nepal?
Your answer should be compact. 2.69e+04. In the year 2002, what is the difference between the Emissions(kt) of Azerbaijan and Emissions(kt) of St. Vincent and the Grenadines?
Provide a short and direct response. 2.94e+04. In the year 2002, what is the difference between the Emissions(kt) of Cabo Verde and Emissions(kt) of Nepal?
Provide a succinct answer. -2464.22. In the year 2002, what is the difference between the Emissions(kt) in Cabo Verde and Emissions(kt) in St. Vincent and the Grenadines?
Your answer should be compact. 58.67. In the year 2002, what is the difference between the Emissions(kt) of Nepal and Emissions(kt) of St. Vincent and the Grenadines?
Provide a succinct answer. 2522.9. In the year 2003, what is the difference between the Emissions(kt) in Azerbaijan and Emissions(kt) in Cabo Verde?
Keep it short and to the point. 3.04e+04. In the year 2003, what is the difference between the Emissions(kt) in Azerbaijan and Emissions(kt) in Nepal?
Provide a short and direct response. 2.77e+04. In the year 2003, what is the difference between the Emissions(kt) in Azerbaijan and Emissions(kt) in St. Vincent and the Grenadines?
Ensure brevity in your answer.  3.04e+04. In the year 2003, what is the difference between the Emissions(kt) in Cabo Verde and Emissions(kt) in Nepal?
Your response must be concise. -2698.91. In the year 2003, what is the difference between the Emissions(kt) of Cabo Verde and Emissions(kt) of St. Vincent and the Grenadines?
Provide a succinct answer. 55.01. In the year 2003, what is the difference between the Emissions(kt) in Nepal and Emissions(kt) in St. Vincent and the Grenadines?
Make the answer very short. 2753.92. In the year 2004, what is the difference between the Emissions(kt) of Azerbaijan and Emissions(kt) of Cabo Verde?
Your response must be concise. 3.18e+04. In the year 2004, what is the difference between the Emissions(kt) in Azerbaijan and Emissions(kt) in Nepal?
Give a very brief answer. 2.93e+04. In the year 2004, what is the difference between the Emissions(kt) of Azerbaijan and Emissions(kt) of St. Vincent and the Grenadines?
Your response must be concise. 3.19e+04. In the year 2004, what is the difference between the Emissions(kt) of Cabo Verde and Emissions(kt) of Nepal?
Your answer should be very brief. -2504.56. In the year 2004, what is the difference between the Emissions(kt) of Cabo Verde and Emissions(kt) of St. Vincent and the Grenadines?
Ensure brevity in your answer.  44. In the year 2004, what is the difference between the Emissions(kt) of Nepal and Emissions(kt) of St. Vincent and the Grenadines?
Give a very brief answer. 2548.57. In the year 2005, what is the difference between the Emissions(kt) of Azerbaijan and Emissions(kt) of Cabo Verde?
Give a very brief answer. 3.40e+04. In the year 2005, what is the difference between the Emissions(kt) in Azerbaijan and Emissions(kt) in Nepal?
Your response must be concise. 3.11e+04. In the year 2005, what is the difference between the Emissions(kt) in Azerbaijan and Emissions(kt) in St. Vincent and the Grenadines?
Make the answer very short. 3.41e+04. In the year 2005, what is the difference between the Emissions(kt) of Cabo Verde and Emissions(kt) of Nepal?
Provide a succinct answer. -2948.27. In the year 2005, what is the difference between the Emissions(kt) of Cabo Verde and Emissions(kt) of St. Vincent and the Grenadines?
Offer a very short reply. 73.34. In the year 2005, what is the difference between the Emissions(kt) in Nepal and Emissions(kt) in St. Vincent and the Grenadines?
Provide a succinct answer. 3021.61. In the year 2006, what is the difference between the Emissions(kt) in Azerbaijan and Emissions(kt) in Cabo Verde?
Give a very brief answer. 3.89e+04. In the year 2006, what is the difference between the Emissions(kt) in Azerbaijan and Emissions(kt) in Nepal?
Provide a short and direct response. 3.65e+04. In the year 2006, what is the difference between the Emissions(kt) in Azerbaijan and Emissions(kt) in St. Vincent and the Grenadines?
Give a very brief answer. 3.89e+04. In the year 2006, what is the difference between the Emissions(kt) in Cabo Verde and Emissions(kt) in Nepal?
Ensure brevity in your answer.  -2354.21. In the year 2006, what is the difference between the Emissions(kt) of Cabo Verde and Emissions(kt) of St. Vincent and the Grenadines?
Your answer should be compact. 88.01. In the year 2006, what is the difference between the Emissions(kt) of Nepal and Emissions(kt) of St. Vincent and the Grenadines?
Your response must be concise. 2442.22. What is the ratio of the Emissions(kt) of Azerbaijan in 2000 to that in 2001?
Your answer should be compact. 1.03. What is the ratio of the Emissions(kt) in Cabo Verde in 2000 to that in 2001?
Make the answer very short. 0.89. What is the ratio of the Emissions(kt) in Nepal in 2000 to that in 2001?
Give a very brief answer. 0.94. What is the ratio of the Emissions(kt) in St. Vincent and the Grenadines in 2000 to that in 2001?
Give a very brief answer. 0.82. What is the ratio of the Emissions(kt) in Cabo Verde in 2000 to that in 2002?
Provide a short and direct response. 0.76. What is the ratio of the Emissions(kt) in Nepal in 2000 to that in 2002?
Your response must be concise. 1.19. What is the ratio of the Emissions(kt) of St. Vincent and the Grenadines in 2000 to that in 2002?
Your answer should be compact. 0.78. What is the ratio of the Emissions(kt) in Azerbaijan in 2000 to that in 2003?
Keep it short and to the point. 0.96. What is the ratio of the Emissions(kt) of Cabo Verde in 2000 to that in 2003?
Keep it short and to the point. 0.74. What is the ratio of the Emissions(kt) of Nepal in 2000 to that in 2003?
Your answer should be compact. 1.1. What is the ratio of the Emissions(kt) in St. Vincent and the Grenadines in 2000 to that in 2003?
Offer a very short reply. 0.74. What is the ratio of the Emissions(kt) of Azerbaijan in 2000 to that in 2004?
Give a very brief answer. 0.92. What is the ratio of the Emissions(kt) in Cabo Verde in 2000 to that in 2004?
Offer a terse response. 0.71. What is the ratio of the Emissions(kt) of Nepal in 2000 to that in 2004?
Provide a succinct answer. 1.17. What is the ratio of the Emissions(kt) in Azerbaijan in 2000 to that in 2005?
Offer a very short reply. 0.86. What is the ratio of the Emissions(kt) of Cabo Verde in 2000 to that in 2005?
Your response must be concise. 0.64. What is the ratio of the Emissions(kt) of Nepal in 2000 to that in 2005?
Offer a terse response. 1. What is the ratio of the Emissions(kt) in Azerbaijan in 2000 to that in 2006?
Your response must be concise. 0.75. What is the ratio of the Emissions(kt) in Cabo Verde in 2000 to that in 2006?
Give a very brief answer. 0.61. What is the ratio of the Emissions(kt) in Nepal in 2000 to that in 2006?
Provide a short and direct response. 1.21. What is the ratio of the Emissions(kt) of St. Vincent and the Grenadines in 2000 to that in 2006?
Keep it short and to the point. 0.67. What is the ratio of the Emissions(kt) in Azerbaijan in 2001 to that in 2002?
Keep it short and to the point. 0.97. What is the ratio of the Emissions(kt) in Cabo Verde in 2001 to that in 2002?
Your response must be concise. 0.85. What is the ratio of the Emissions(kt) in Nepal in 2001 to that in 2002?
Offer a very short reply. 1.27. What is the ratio of the Emissions(kt) in St. Vincent and the Grenadines in 2001 to that in 2002?
Make the answer very short. 0.96. What is the ratio of the Emissions(kt) in Azerbaijan in 2001 to that in 2003?
Make the answer very short. 0.94. What is the ratio of the Emissions(kt) of Cabo Verde in 2001 to that in 2003?
Provide a succinct answer. 0.83. What is the ratio of the Emissions(kt) in Nepal in 2001 to that in 2003?
Make the answer very short. 1.17. What is the ratio of the Emissions(kt) of St. Vincent and the Grenadines in 2001 to that in 2003?
Your response must be concise. 0.91. What is the ratio of the Emissions(kt) of Azerbaijan in 2001 to that in 2004?
Provide a succinct answer. 0.9. What is the ratio of the Emissions(kt) of Cabo Verde in 2001 to that in 2004?
Keep it short and to the point. 0.79. What is the ratio of the Emissions(kt) in Nepal in 2001 to that in 2004?
Your response must be concise. 1.25. What is the ratio of the Emissions(kt) in St. Vincent and the Grenadines in 2001 to that in 2004?
Your response must be concise. 0.82. What is the ratio of the Emissions(kt) in Azerbaijan in 2001 to that in 2005?
Provide a succinct answer. 0.84. What is the ratio of the Emissions(kt) of Cabo Verde in 2001 to that in 2005?
Provide a succinct answer. 0.71. What is the ratio of the Emissions(kt) of Nepal in 2001 to that in 2005?
Your answer should be very brief. 1.07. What is the ratio of the Emissions(kt) in St. Vincent and the Grenadines in 2001 to that in 2005?
Provide a succinct answer. 0.82. What is the ratio of the Emissions(kt) of Azerbaijan in 2001 to that in 2006?
Offer a terse response. 0.73. What is the ratio of the Emissions(kt) of Cabo Verde in 2001 to that in 2006?
Make the answer very short. 0.68. What is the ratio of the Emissions(kt) in Nepal in 2001 to that in 2006?
Offer a terse response. 1.3. What is the ratio of the Emissions(kt) in St. Vincent and the Grenadines in 2001 to that in 2006?
Your answer should be compact. 0.82. What is the ratio of the Emissions(kt) of Azerbaijan in 2002 to that in 2003?
Your answer should be compact. 0.97. What is the ratio of the Emissions(kt) of Cabo Verde in 2002 to that in 2003?
Ensure brevity in your answer.  0.97. What is the ratio of the Emissions(kt) of Nepal in 2002 to that in 2003?
Offer a terse response. 0.92. What is the ratio of the Emissions(kt) of Azerbaijan in 2002 to that in 2004?
Provide a short and direct response. 0.92. What is the ratio of the Emissions(kt) of Cabo Verde in 2002 to that in 2004?
Provide a short and direct response. 0.93. What is the ratio of the Emissions(kt) in Nepal in 2002 to that in 2004?
Keep it short and to the point. 0.98. What is the ratio of the Emissions(kt) in St. Vincent and the Grenadines in 2002 to that in 2004?
Keep it short and to the point. 0.85. What is the ratio of the Emissions(kt) in Azerbaijan in 2002 to that in 2005?
Give a very brief answer. 0.86. What is the ratio of the Emissions(kt) of Cabo Verde in 2002 to that in 2005?
Ensure brevity in your answer.  0.84. What is the ratio of the Emissions(kt) in Nepal in 2002 to that in 2005?
Give a very brief answer. 0.84. What is the ratio of the Emissions(kt) in St. Vincent and the Grenadines in 2002 to that in 2005?
Offer a terse response. 0.85. What is the ratio of the Emissions(kt) of Azerbaijan in 2002 to that in 2006?
Provide a succinct answer. 0.76. What is the ratio of the Emissions(kt) in Cabo Verde in 2002 to that in 2006?
Provide a short and direct response. 0.8. What is the ratio of the Emissions(kt) in Nepal in 2002 to that in 2006?
Your answer should be very brief. 1.02. What is the ratio of the Emissions(kt) of Azerbaijan in 2003 to that in 2004?
Offer a terse response. 0.95. What is the ratio of the Emissions(kt) of Nepal in 2003 to that in 2004?
Give a very brief answer. 1.07. What is the ratio of the Emissions(kt) in St. Vincent and the Grenadines in 2003 to that in 2004?
Give a very brief answer. 0.9. What is the ratio of the Emissions(kt) of Azerbaijan in 2003 to that in 2005?
Give a very brief answer. 0.89. What is the ratio of the Emissions(kt) in Cabo Verde in 2003 to that in 2005?
Your answer should be very brief. 0.86. What is the ratio of the Emissions(kt) of Nepal in 2003 to that in 2005?
Make the answer very short. 0.91. What is the ratio of the Emissions(kt) of St. Vincent and the Grenadines in 2003 to that in 2005?
Your answer should be compact. 0.9. What is the ratio of the Emissions(kt) of Azerbaijan in 2003 to that in 2006?
Give a very brief answer. 0.78. What is the ratio of the Emissions(kt) of Cabo Verde in 2003 to that in 2006?
Your answer should be compact. 0.82. What is the ratio of the Emissions(kt) of Nepal in 2003 to that in 2006?
Your response must be concise. 1.11. What is the ratio of the Emissions(kt) of Azerbaijan in 2004 to that in 2005?
Keep it short and to the point. 0.93. What is the ratio of the Emissions(kt) in Cabo Verde in 2004 to that in 2005?
Ensure brevity in your answer.  0.9. What is the ratio of the Emissions(kt) in Nepal in 2004 to that in 2005?
Provide a short and direct response. 0.85. What is the ratio of the Emissions(kt) of Azerbaijan in 2004 to that in 2006?
Keep it short and to the point. 0.82. What is the ratio of the Emissions(kt) of Cabo Verde in 2004 to that in 2006?
Your answer should be very brief. 0.86. What is the ratio of the Emissions(kt) in Nepal in 2004 to that in 2006?
Make the answer very short. 1.04. What is the ratio of the Emissions(kt) in St. Vincent and the Grenadines in 2004 to that in 2006?
Offer a very short reply. 1. What is the ratio of the Emissions(kt) of Azerbaijan in 2005 to that in 2006?
Offer a very short reply. 0.88. What is the ratio of the Emissions(kt) of Nepal in 2005 to that in 2006?
Provide a succinct answer. 1.22. What is the ratio of the Emissions(kt) of St. Vincent and the Grenadines in 2005 to that in 2006?
Provide a short and direct response. 1. What is the difference between the highest and the second highest Emissions(kt) of Azerbaijan?
Your answer should be very brief. 4829.44. What is the difference between the highest and the second highest Emissions(kt) in Cabo Verde?
Ensure brevity in your answer.  14.67. What is the difference between the highest and the second highest Emissions(kt) of Nepal?
Provide a short and direct response. 212.69. What is the difference between the highest and the second highest Emissions(kt) of St. Vincent and the Grenadines?
Make the answer very short. 0. What is the difference between the highest and the lowest Emissions(kt) in Azerbaijan?
Provide a short and direct response. 1.04e+04. What is the difference between the highest and the lowest Emissions(kt) of Cabo Verde?
Offer a terse response. 121.01. What is the difference between the highest and the lowest Emissions(kt) in Nepal?
Provide a short and direct response. 792.07. What is the difference between the highest and the lowest Emissions(kt) of St. Vincent and the Grenadines?
Provide a succinct answer. 73.34. 